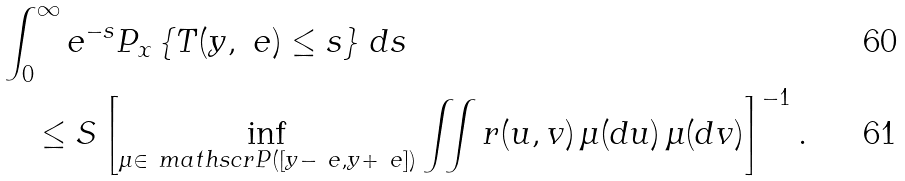Convert formula to latex. <formula><loc_0><loc_0><loc_500><loc_500>& \int _ { 0 } ^ { \infty } e ^ { - s } P _ { x } \left \{ T ( y , \ e ) \leq s \right \} \, d s \\ & \quad \leq S \left [ \inf _ { \mu \in \ m a t h s c r { P } ( [ y - \ e , y + \ e ] ) } \iint r ( u , v ) \, \mu ( d u ) \, \mu ( d v ) \right ] ^ { - 1 } .</formula> 